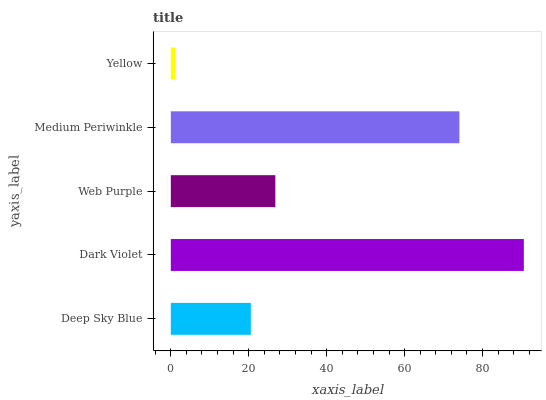Is Yellow the minimum?
Answer yes or no. Yes. Is Dark Violet the maximum?
Answer yes or no. Yes. Is Web Purple the minimum?
Answer yes or no. No. Is Web Purple the maximum?
Answer yes or no. No. Is Dark Violet greater than Web Purple?
Answer yes or no. Yes. Is Web Purple less than Dark Violet?
Answer yes or no. Yes. Is Web Purple greater than Dark Violet?
Answer yes or no. No. Is Dark Violet less than Web Purple?
Answer yes or no. No. Is Web Purple the high median?
Answer yes or no. Yes. Is Web Purple the low median?
Answer yes or no. Yes. Is Yellow the high median?
Answer yes or no. No. Is Medium Periwinkle the low median?
Answer yes or no. No. 